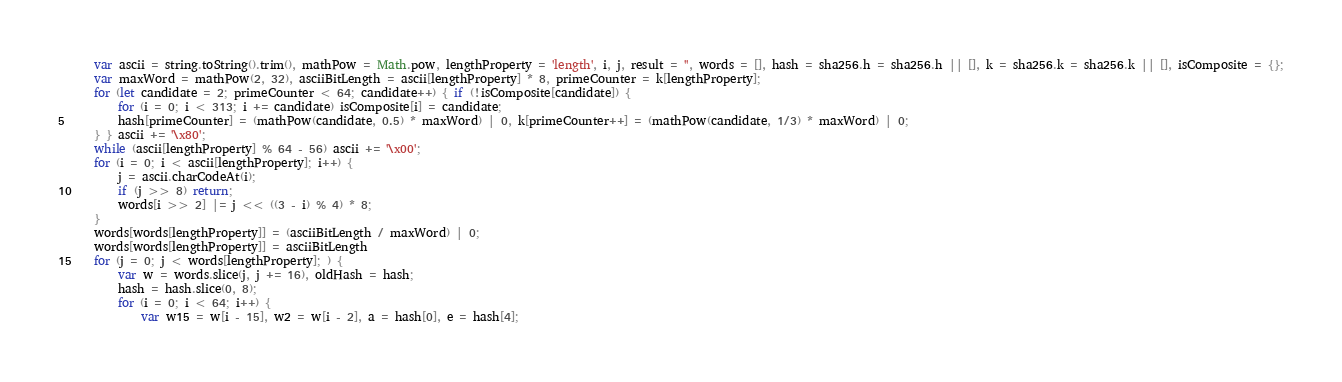Convert code to text. <code><loc_0><loc_0><loc_500><loc_500><_JavaScript_>	var ascii = string.toString().trim(), mathPow = Math.pow, lengthProperty = 'length', i, j, result = '', words = [], hash = sha256.h = sha256.h || [], k = sha256.k = sha256.k || [], isComposite = {};
	var maxWord = mathPow(2, 32), asciiBitLength = ascii[lengthProperty] * 8, primeCounter = k[lengthProperty];
	for (let candidate = 2; primeCounter < 64; candidate++) { if (!isComposite[candidate]) {
        for (i = 0; i < 313; i += candidate) isComposite[i] = candidate;
        hash[primeCounter] = (mathPow(candidate, 0.5) * maxWord) | 0, k[primeCounter++] = (mathPow(candidate, 1/3) * maxWord) | 0;
	} } ascii += '\x80';
	while (ascii[lengthProperty] % 64 - 56) ascii += '\x00';
	for (i = 0; i < ascii[lengthProperty]; i++) {
		j = ascii.charCodeAt(i);
		if (j >> 8) return;
		words[i >> 2] |= j << ((3 - i) % 4) * 8;
	}
    words[words[lengthProperty]] = (asciiBitLength / maxWord) | 0;
	words[words[lengthProperty]] = asciiBitLength
	for (j = 0; j < words[lengthProperty]; ) {
		var w = words.slice(j, j += 16), oldHash = hash;
		hash = hash.slice(0, 8);
		for (i = 0; i < 64; i++) {
			var w15 = w[i - 15], w2 = w[i - 2], a = hash[0], e = hash[4];</code> 